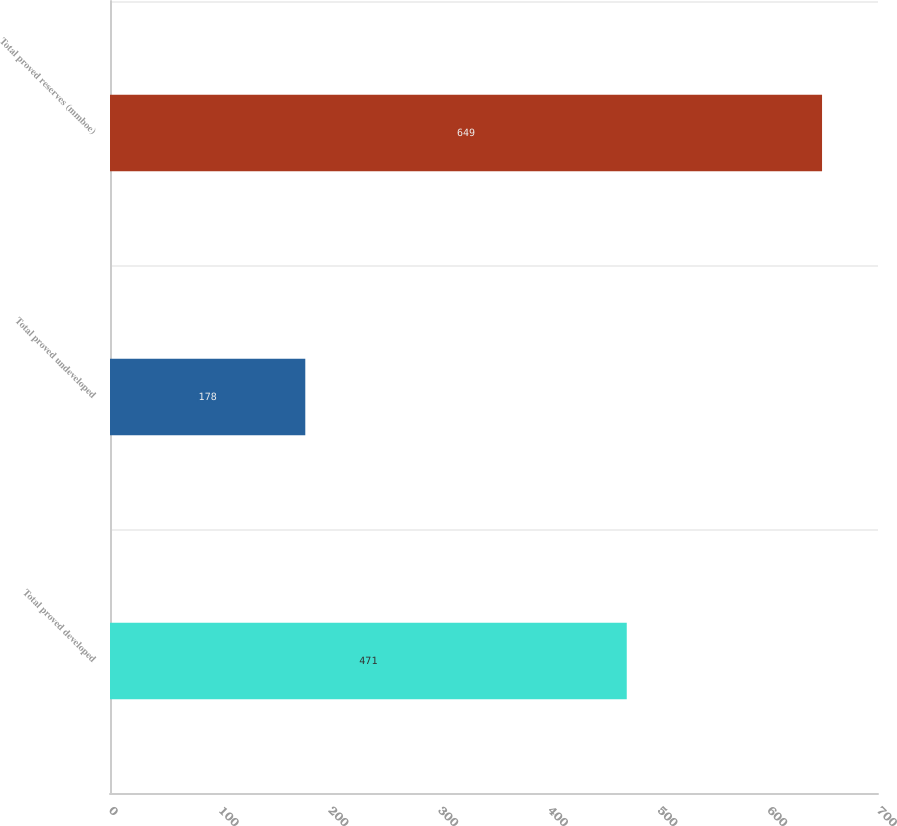<chart> <loc_0><loc_0><loc_500><loc_500><bar_chart><fcel>Total proved developed<fcel>Total proved undeveloped<fcel>Total proved reserves (mmboe)<nl><fcel>471<fcel>178<fcel>649<nl></chart> 